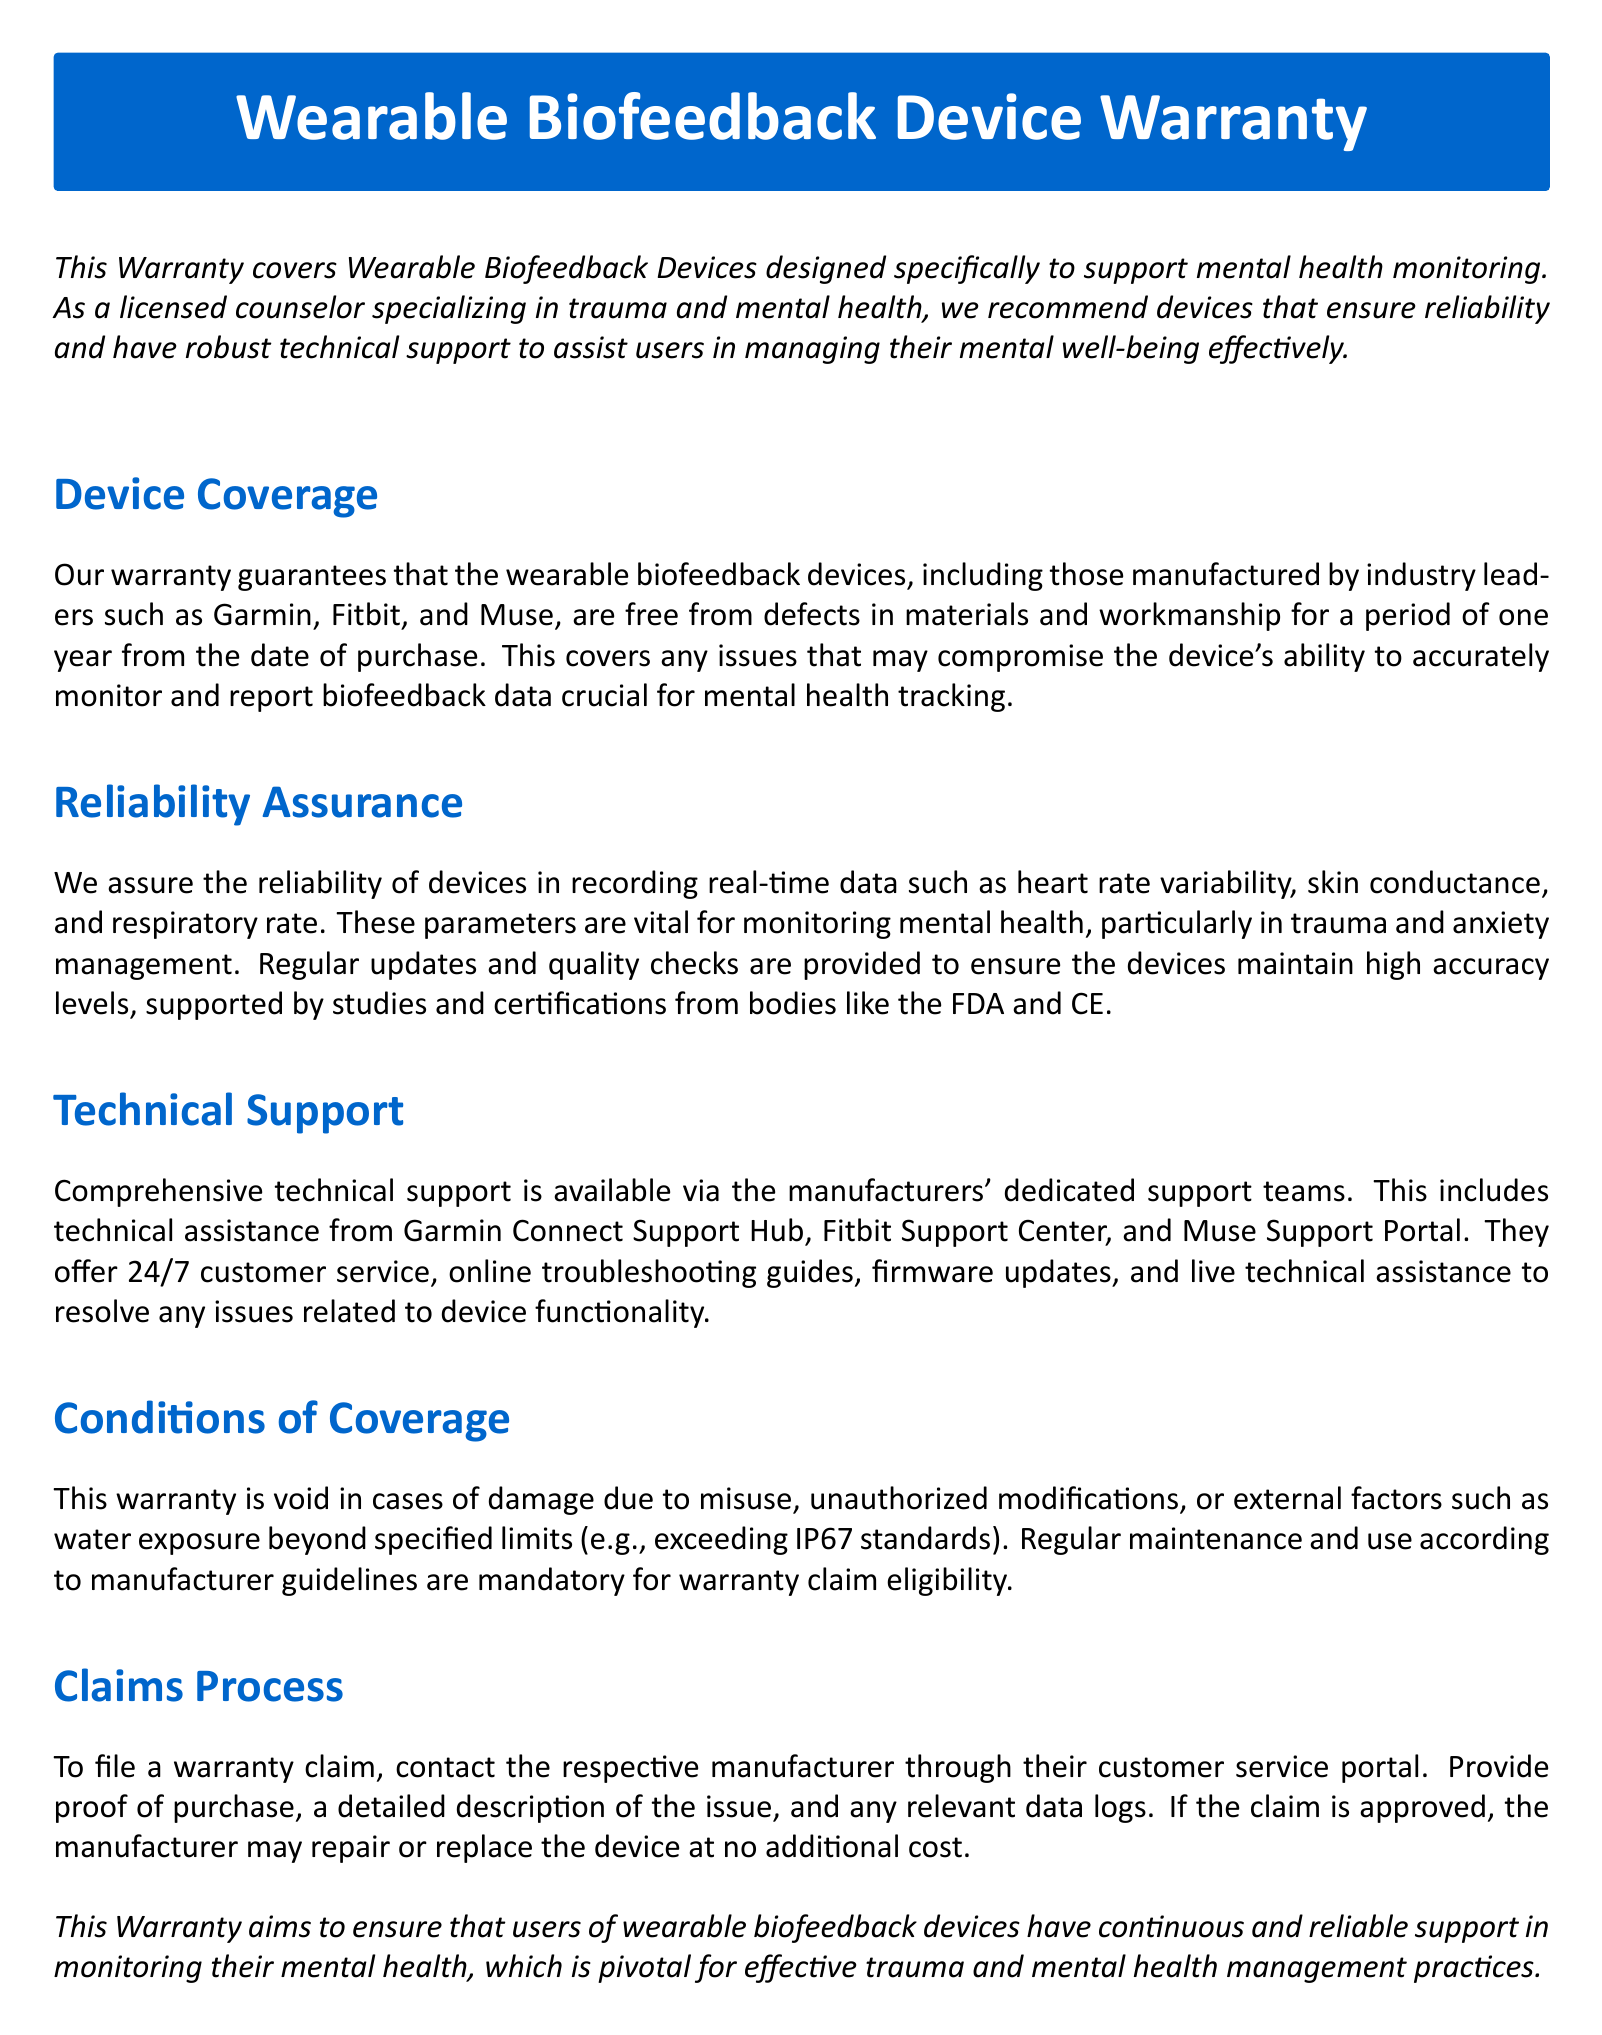What is the warranty period for the devices? The warranty period for the wearable biofeedback devices is one year from the date of purchase.
Answer: one year Which manufacturers are covered under this warranty? The warranty covers devices manufactured by Garmin, Fitbit, and Muse.
Answer: Garmin, Fitbit, and Muse What type of data do the devices monitor? The devices monitor real-time data such as heart rate variability, skin conductance, and respiratory rate.
Answer: heart rate variability, skin conductance, and respiratory rate What is required for warranty claim eligibility? Regular maintenance and use according to manufacturer guidelines are required for warranty claim eligibility.
Answer: regular maintenance and use according to manufacturer guidelines What is the customer service availability for technical support? Technical support is available 24/7 from manufacturers' dedicated support teams.
Answer: 24/7 What voids the warranty coverage? The warranty is void in cases of damage due to misuse, unauthorized modifications, or external factors.
Answer: misuse, unauthorized modifications, or external factors 